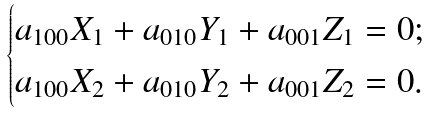Convert formula to latex. <formula><loc_0><loc_0><loc_500><loc_500>\begin{cases} a _ { 1 0 0 } X _ { 1 } + a _ { 0 1 0 } Y _ { 1 } + a _ { 0 0 1 } Z _ { 1 } = 0 ; \\ a _ { 1 0 0 } X _ { 2 } + a _ { 0 1 0 } Y _ { 2 } + a _ { 0 0 1 } Z _ { 2 } = 0 . \end{cases}</formula> 